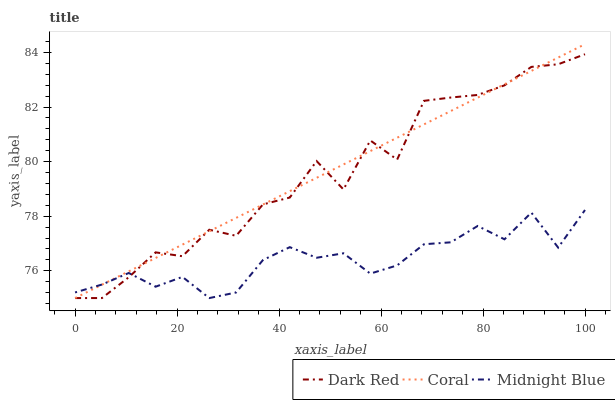Does Midnight Blue have the minimum area under the curve?
Answer yes or no. Yes. Does Coral have the maximum area under the curve?
Answer yes or no. Yes. Does Coral have the minimum area under the curve?
Answer yes or no. No. Does Midnight Blue have the maximum area under the curve?
Answer yes or no. No. Is Coral the smoothest?
Answer yes or no. Yes. Is Dark Red the roughest?
Answer yes or no. Yes. Is Midnight Blue the smoothest?
Answer yes or no. No. Is Midnight Blue the roughest?
Answer yes or no. No. Does Dark Red have the lowest value?
Answer yes or no. Yes. Does Coral have the highest value?
Answer yes or no. Yes. Does Midnight Blue have the highest value?
Answer yes or no. No. Does Coral intersect Midnight Blue?
Answer yes or no. Yes. Is Coral less than Midnight Blue?
Answer yes or no. No. Is Coral greater than Midnight Blue?
Answer yes or no. No. 